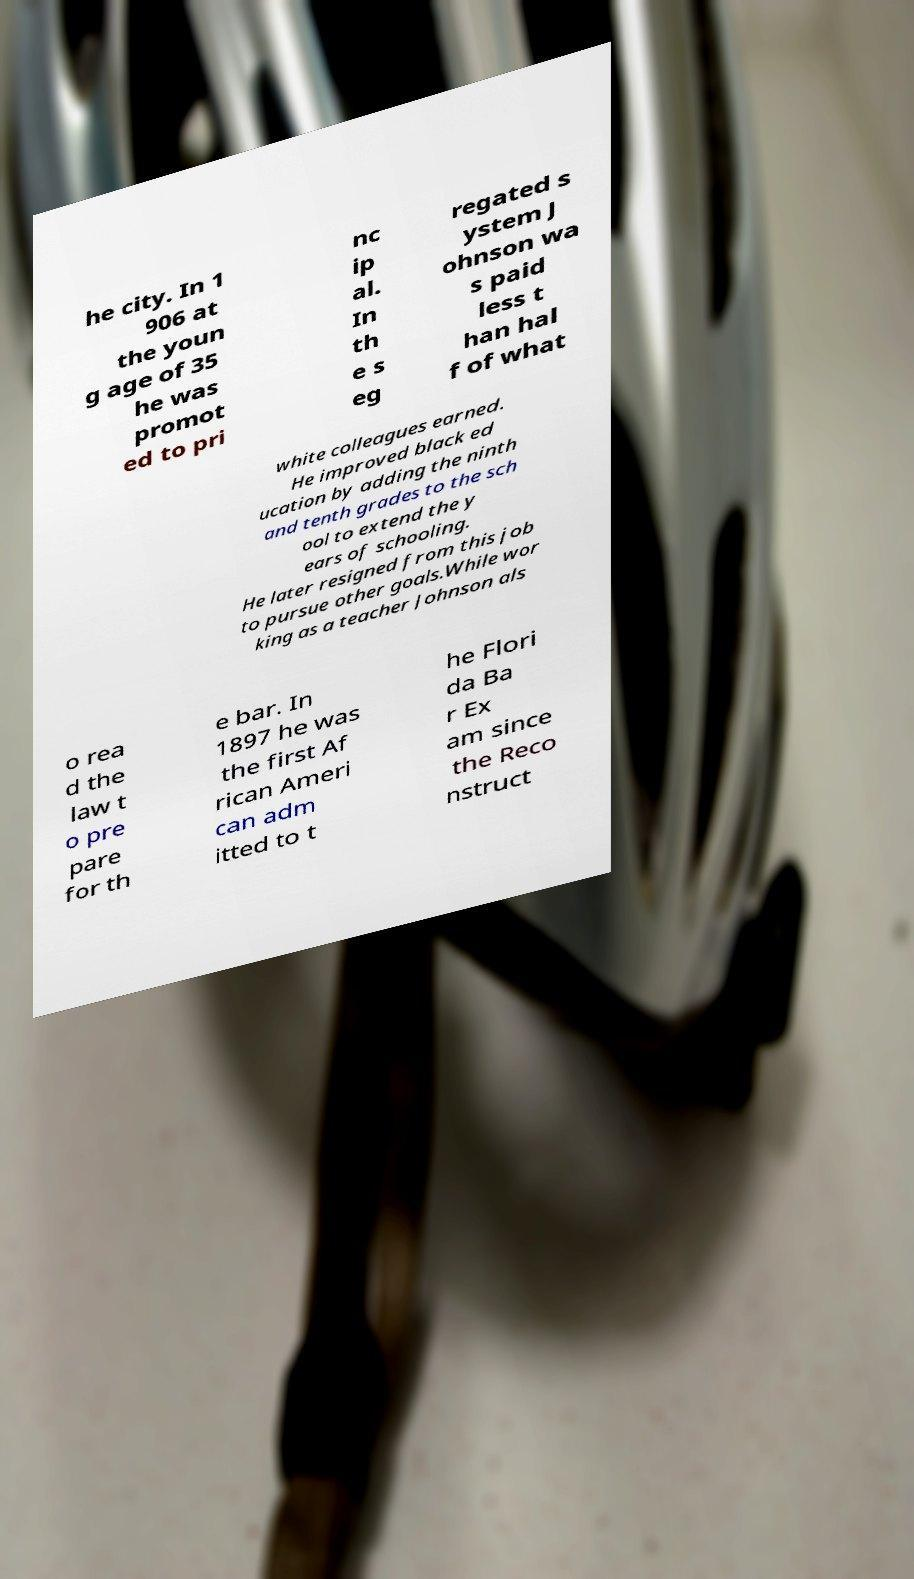Please read and relay the text visible in this image. What does it say? he city. In 1 906 at the youn g age of 35 he was promot ed to pri nc ip al. In th e s eg regated s ystem J ohnson wa s paid less t han hal f of what white colleagues earned. He improved black ed ucation by adding the ninth and tenth grades to the sch ool to extend the y ears of schooling. He later resigned from this job to pursue other goals.While wor king as a teacher Johnson als o rea d the law t o pre pare for th e bar. In 1897 he was the first Af rican Ameri can adm itted to t he Flori da Ba r Ex am since the Reco nstruct 